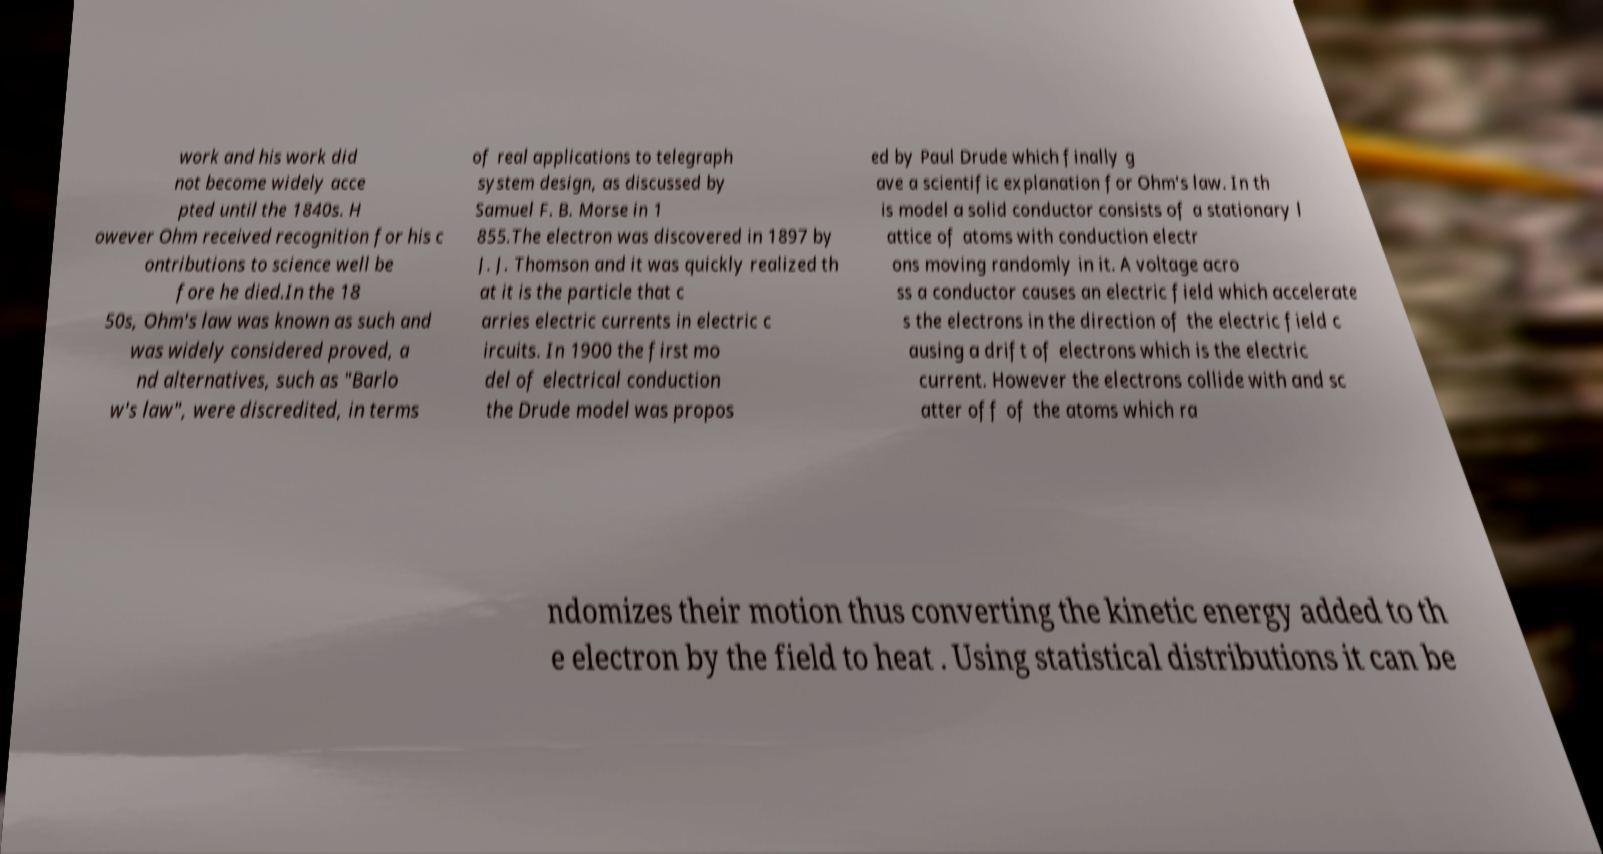Can you accurately transcribe the text from the provided image for me? work and his work did not become widely acce pted until the 1840s. H owever Ohm received recognition for his c ontributions to science well be fore he died.In the 18 50s, Ohm's law was known as such and was widely considered proved, a nd alternatives, such as "Barlo w's law", were discredited, in terms of real applications to telegraph system design, as discussed by Samuel F. B. Morse in 1 855.The electron was discovered in 1897 by J. J. Thomson and it was quickly realized th at it is the particle that c arries electric currents in electric c ircuits. In 1900 the first mo del of electrical conduction the Drude model was propos ed by Paul Drude which finally g ave a scientific explanation for Ohm's law. In th is model a solid conductor consists of a stationary l attice of atoms with conduction electr ons moving randomly in it. A voltage acro ss a conductor causes an electric field which accelerate s the electrons in the direction of the electric field c ausing a drift of electrons which is the electric current. However the electrons collide with and sc atter off of the atoms which ra ndomizes their motion thus converting the kinetic energy added to th e electron by the field to heat . Using statistical distributions it can be 